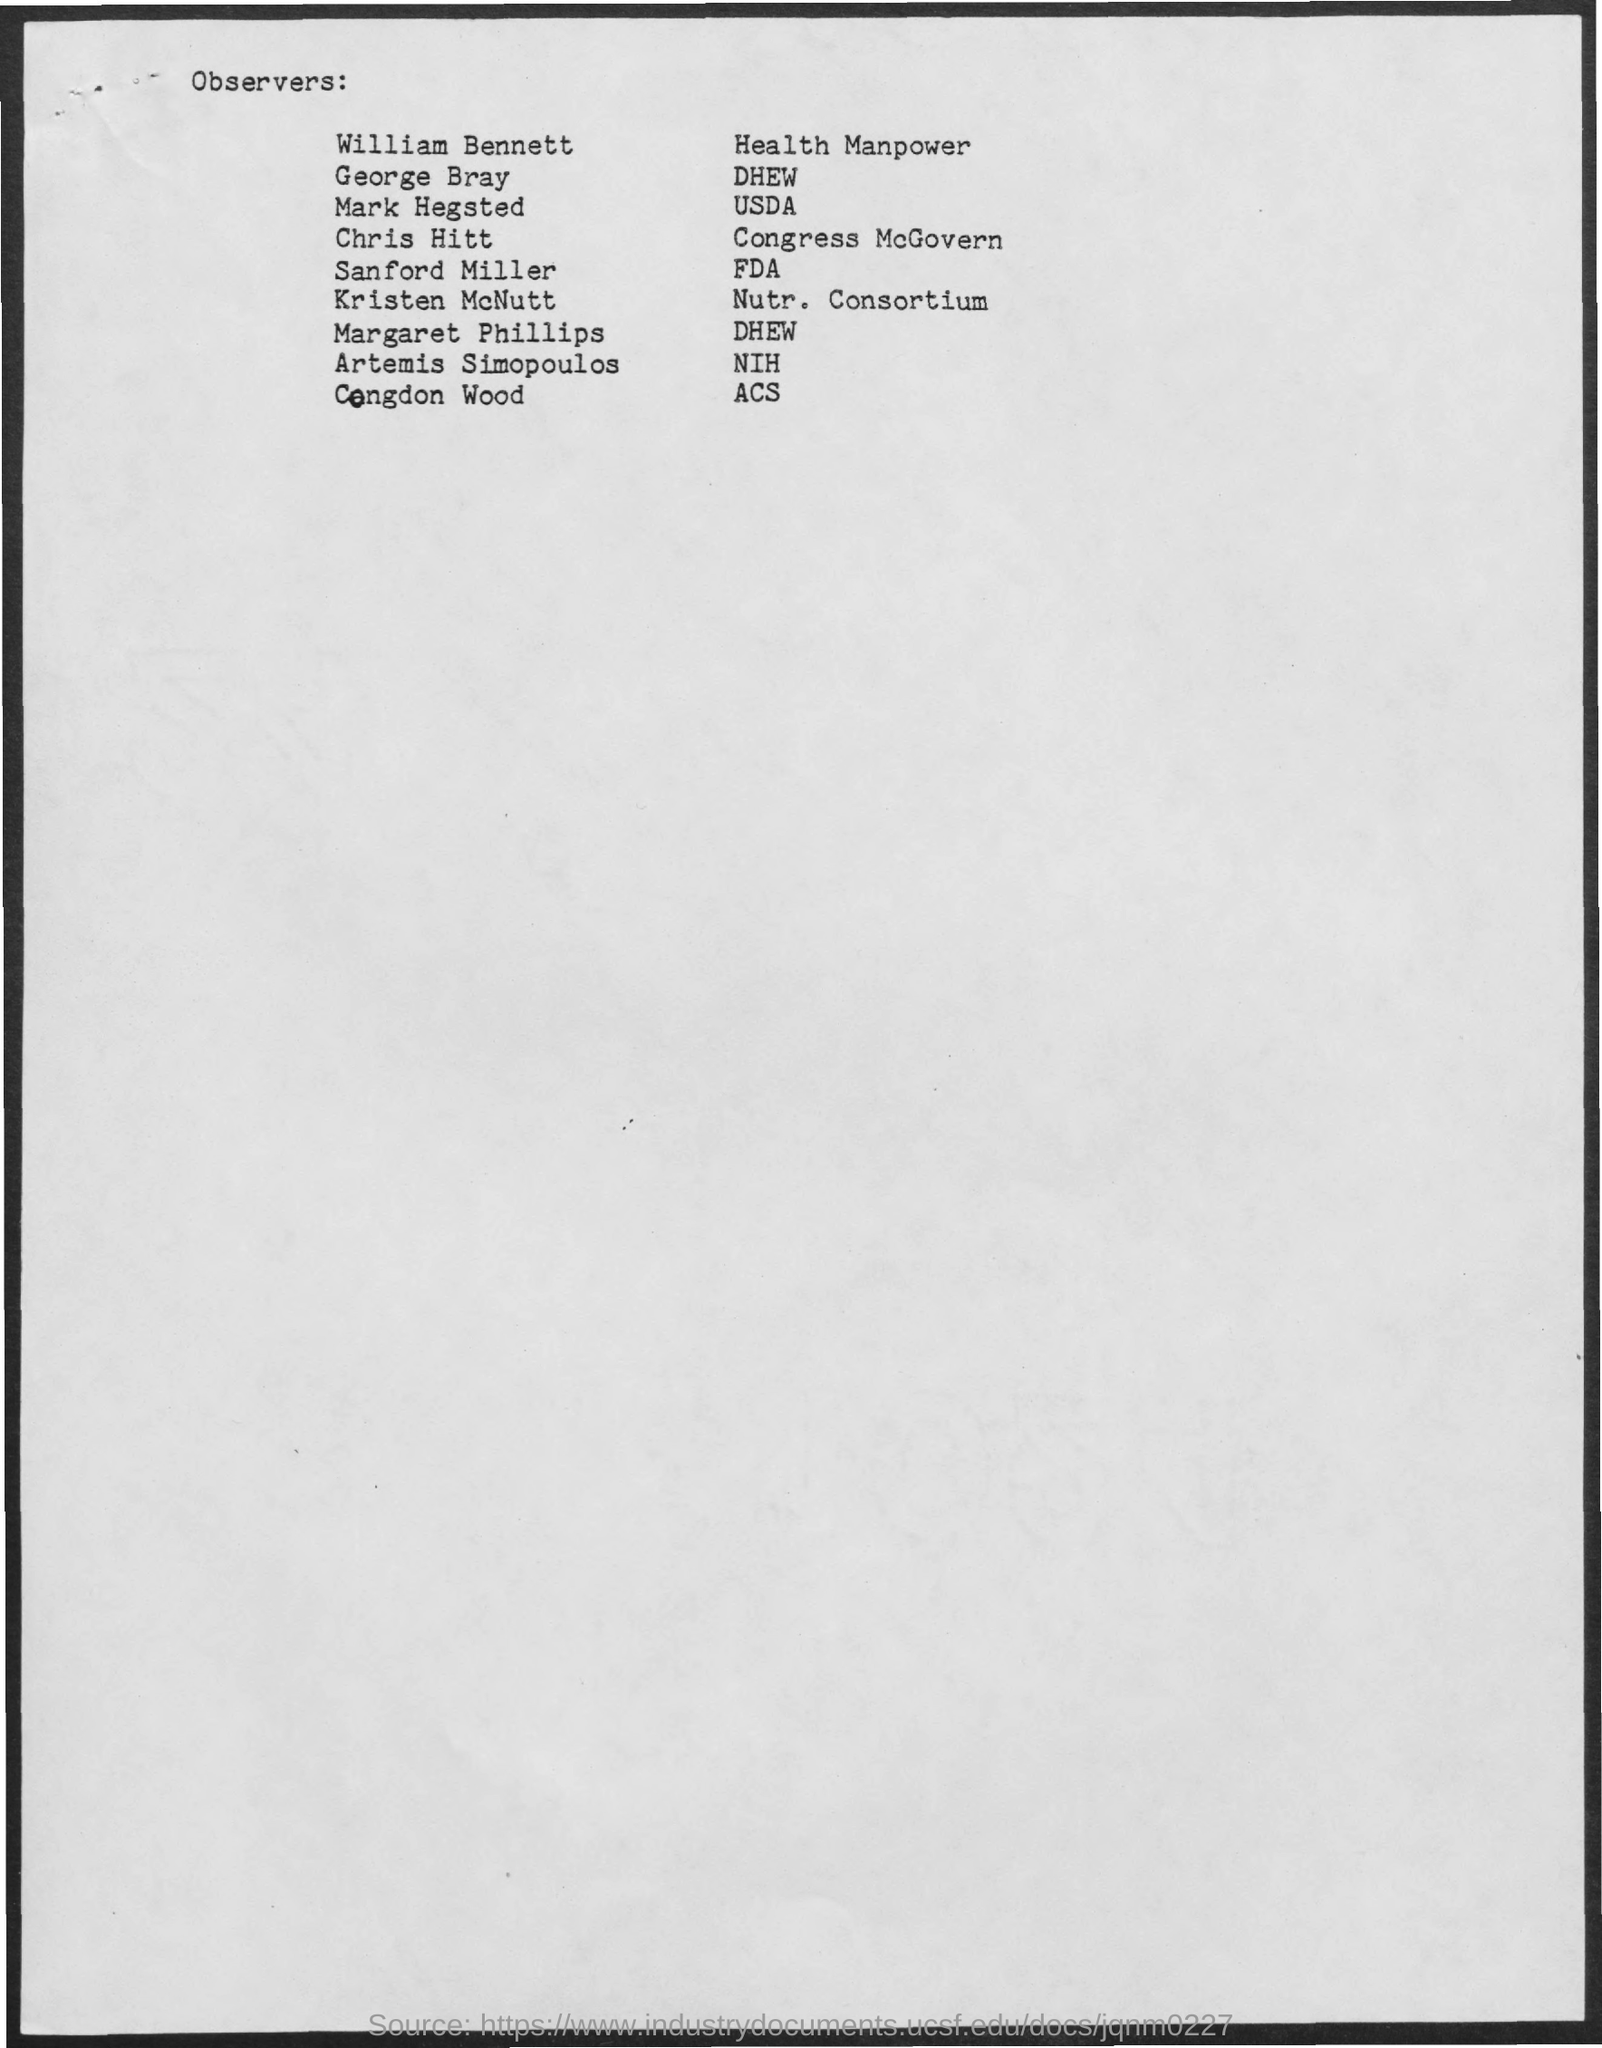Give some essential details in this illustration. The Department of Health, Education, and Welfare is observed by George Bray. 